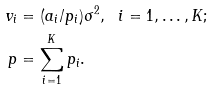<formula> <loc_0><loc_0><loc_500><loc_500>v _ { i } & = ( a _ { i } / p _ { i } ) \sigma ^ { 2 } , \ \ i = 1 , \dots , K ; \\ p & = \sum _ { i = 1 } ^ { K } p _ { i } .</formula> 